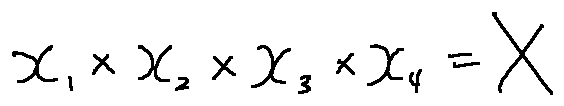Convert formula to latex. <formula><loc_0><loc_0><loc_500><loc_500>x _ { 1 } \times x _ { 2 } \times x _ { 3 } \times x _ { 4 } = X</formula> 